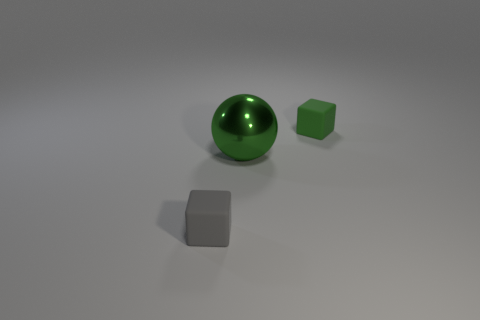Is there any other thing that is the same material as the large ball?
Provide a succinct answer. No. What is the color of the big metallic sphere?
Offer a terse response. Green. Is the number of green things that are left of the gray matte block less than the number of small gray metal blocks?
Offer a terse response. No. Is there anything else that has the same shape as the large shiny object?
Ensure brevity in your answer.  No. Are any small gray cubes visible?
Your response must be concise. Yes. Are there fewer green rubber things than big red rubber cubes?
Keep it short and to the point. No. What number of balls have the same material as the green block?
Offer a terse response. 0. What color is the tiny object that is the same material as the tiny gray cube?
Make the answer very short. Green. What is the shape of the green metallic thing?
Provide a short and direct response. Sphere. How many rubber blocks are the same color as the ball?
Keep it short and to the point. 1. 